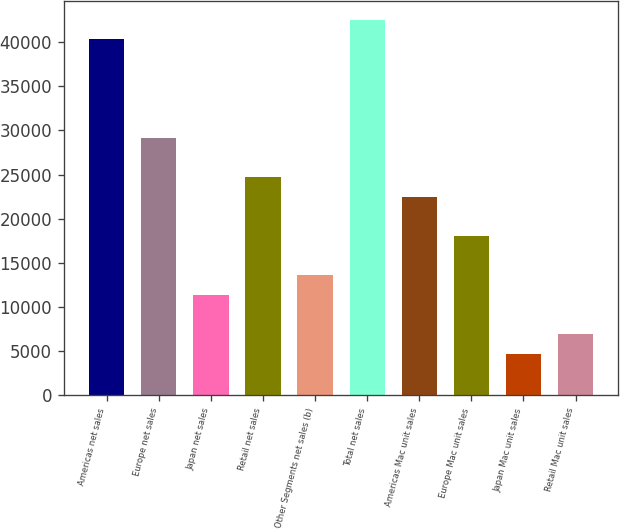Convert chart to OTSL. <chart><loc_0><loc_0><loc_500><loc_500><bar_chart><fcel>Americas net sales<fcel>Europe net sales<fcel>Japan net sales<fcel>Retail net sales<fcel>Other Segments net sales (b)<fcel>Total net sales<fcel>Americas Mac unit sales<fcel>Europe Mac unit sales<fcel>Japan Mac unit sales<fcel>Retail Mac unit sales<nl><fcel>40333<fcel>29185.5<fcel>11349.5<fcel>24726.5<fcel>13579<fcel>42562.5<fcel>22497<fcel>18038<fcel>4661<fcel>6890.5<nl></chart> 